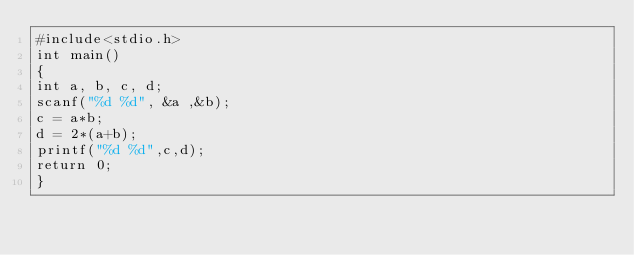Convert code to text. <code><loc_0><loc_0><loc_500><loc_500><_C_>#include<stdio.h>
int main()
{
int a, b, c, d;
scanf("%d %d", &a ,&b);
c = a*b;
d = 2*(a+b);
printf("%d %d",c,d);
return 0;
}
</code> 